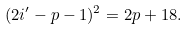<formula> <loc_0><loc_0><loc_500><loc_500>( 2 i ^ { \prime } - p - 1 ) ^ { 2 } = 2 p + 1 8 .</formula> 